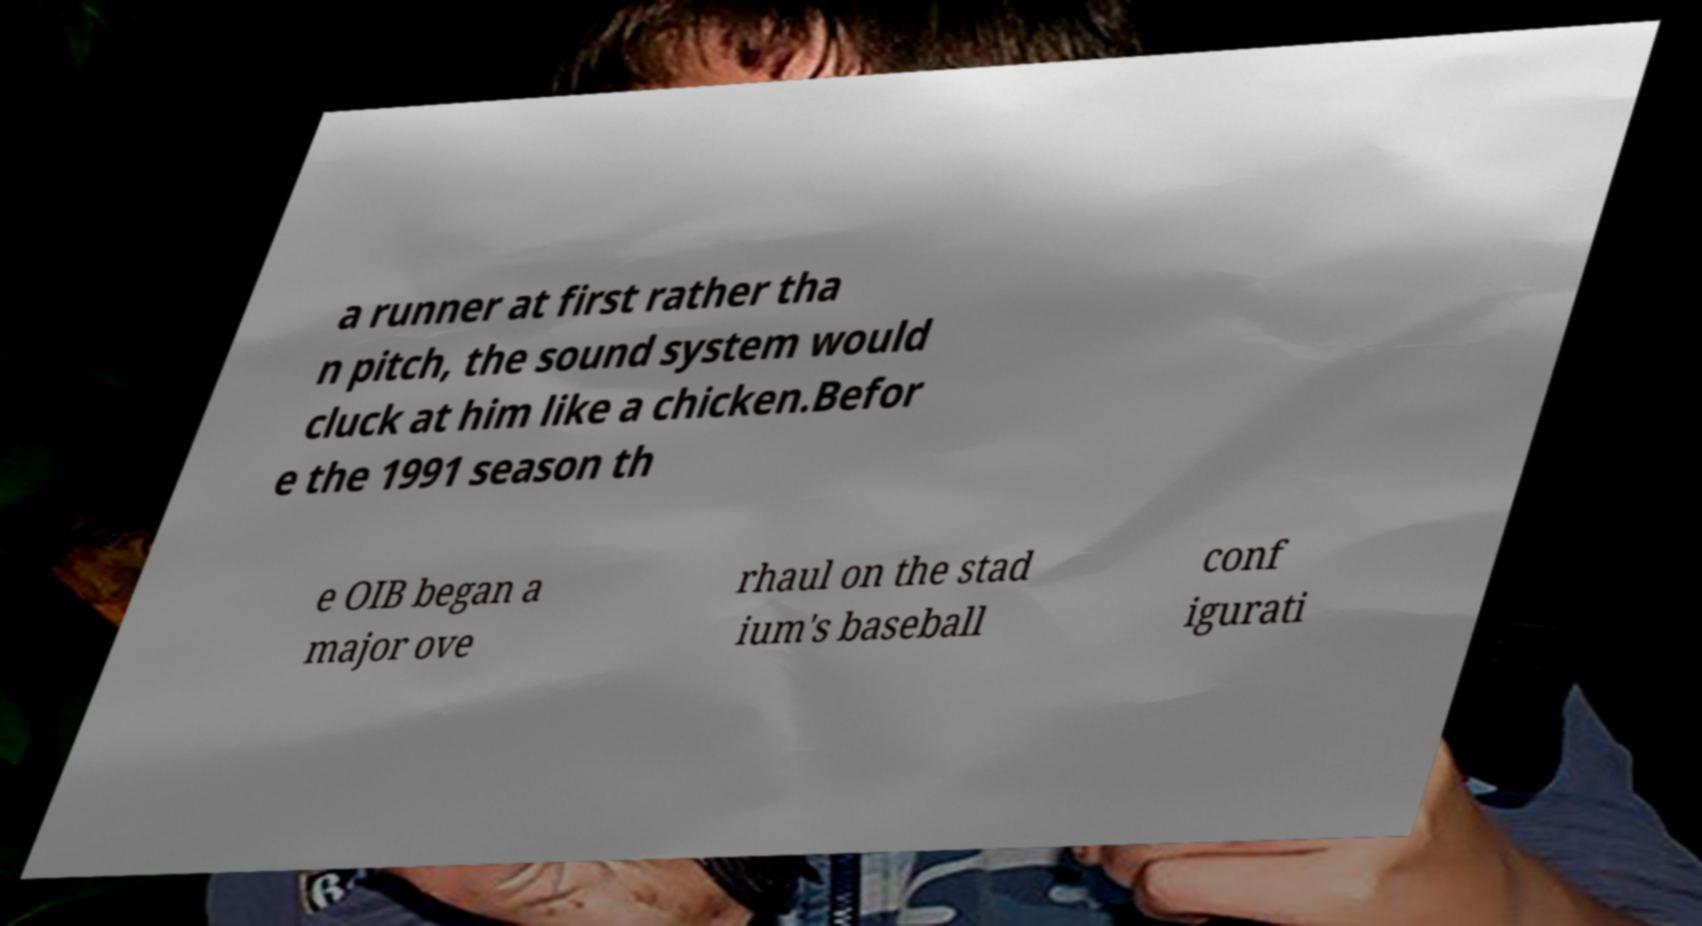What messages or text are displayed in this image? I need them in a readable, typed format. a runner at first rather tha n pitch, the sound system would cluck at him like a chicken.Befor e the 1991 season th e OIB began a major ove rhaul on the stad ium's baseball conf igurati 